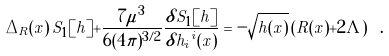<formula> <loc_0><loc_0><loc_500><loc_500>\Delta _ { R } ( x ) \, S _ { 1 } [ h ] + \frac { 7 \mu ^ { 3 } } { 6 ( 4 \pi ) ^ { 3 / 2 } } \frac { \delta S _ { 1 } [ h ] } { \delta { h _ { i } } ^ { i } ( x ) } = - \sqrt { h ( x ) } \left ( R ( x ) + 2 \Lambda \right ) \ .</formula> 